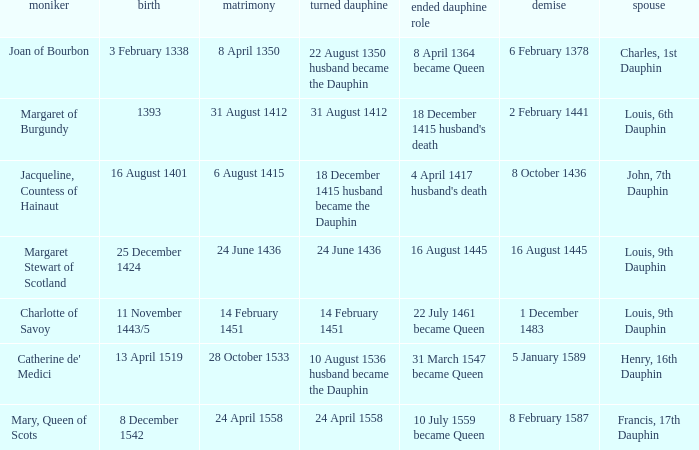Who is the husband when ceased to be dauphine is 22 july 1461 became queen? Louis, 9th Dauphin. 